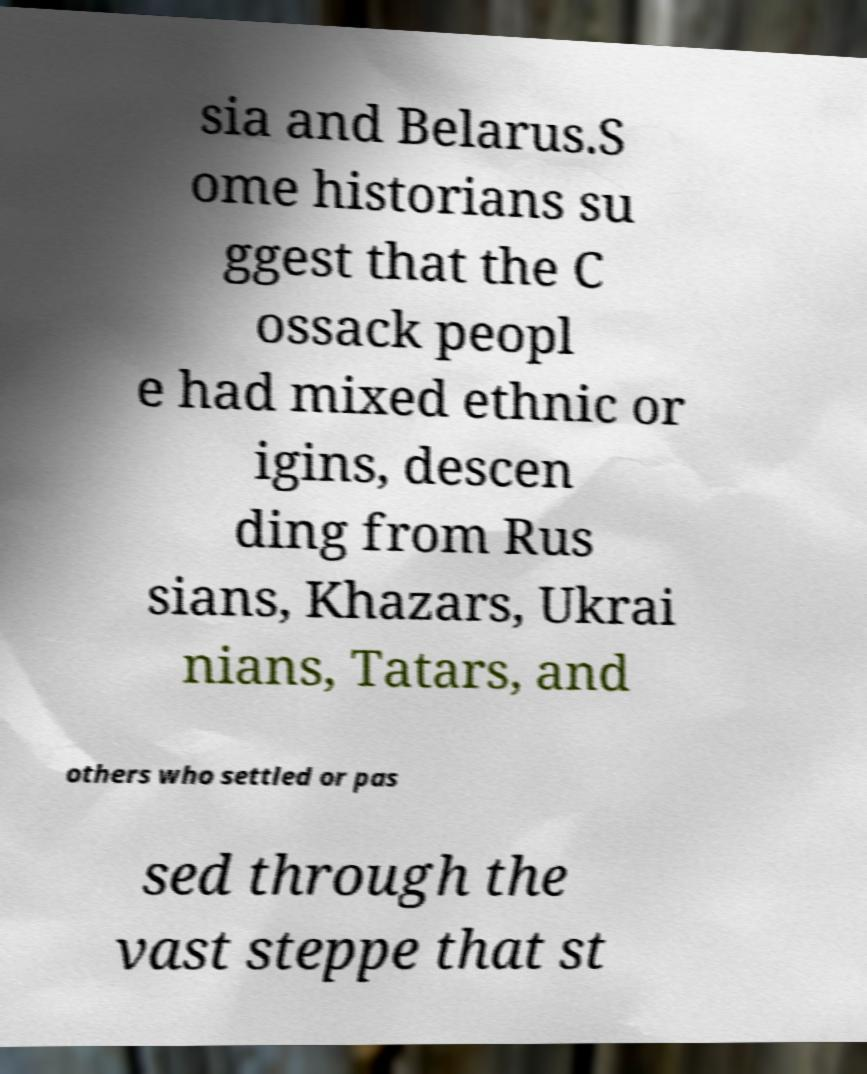Please read and relay the text visible in this image. What does it say? sia and Belarus.S ome historians su ggest that the C ossack peopl e had mixed ethnic or igins, descen ding from Rus sians, Khazars, Ukrai nians, Tatars, and others who settled or pas sed through the vast steppe that st 